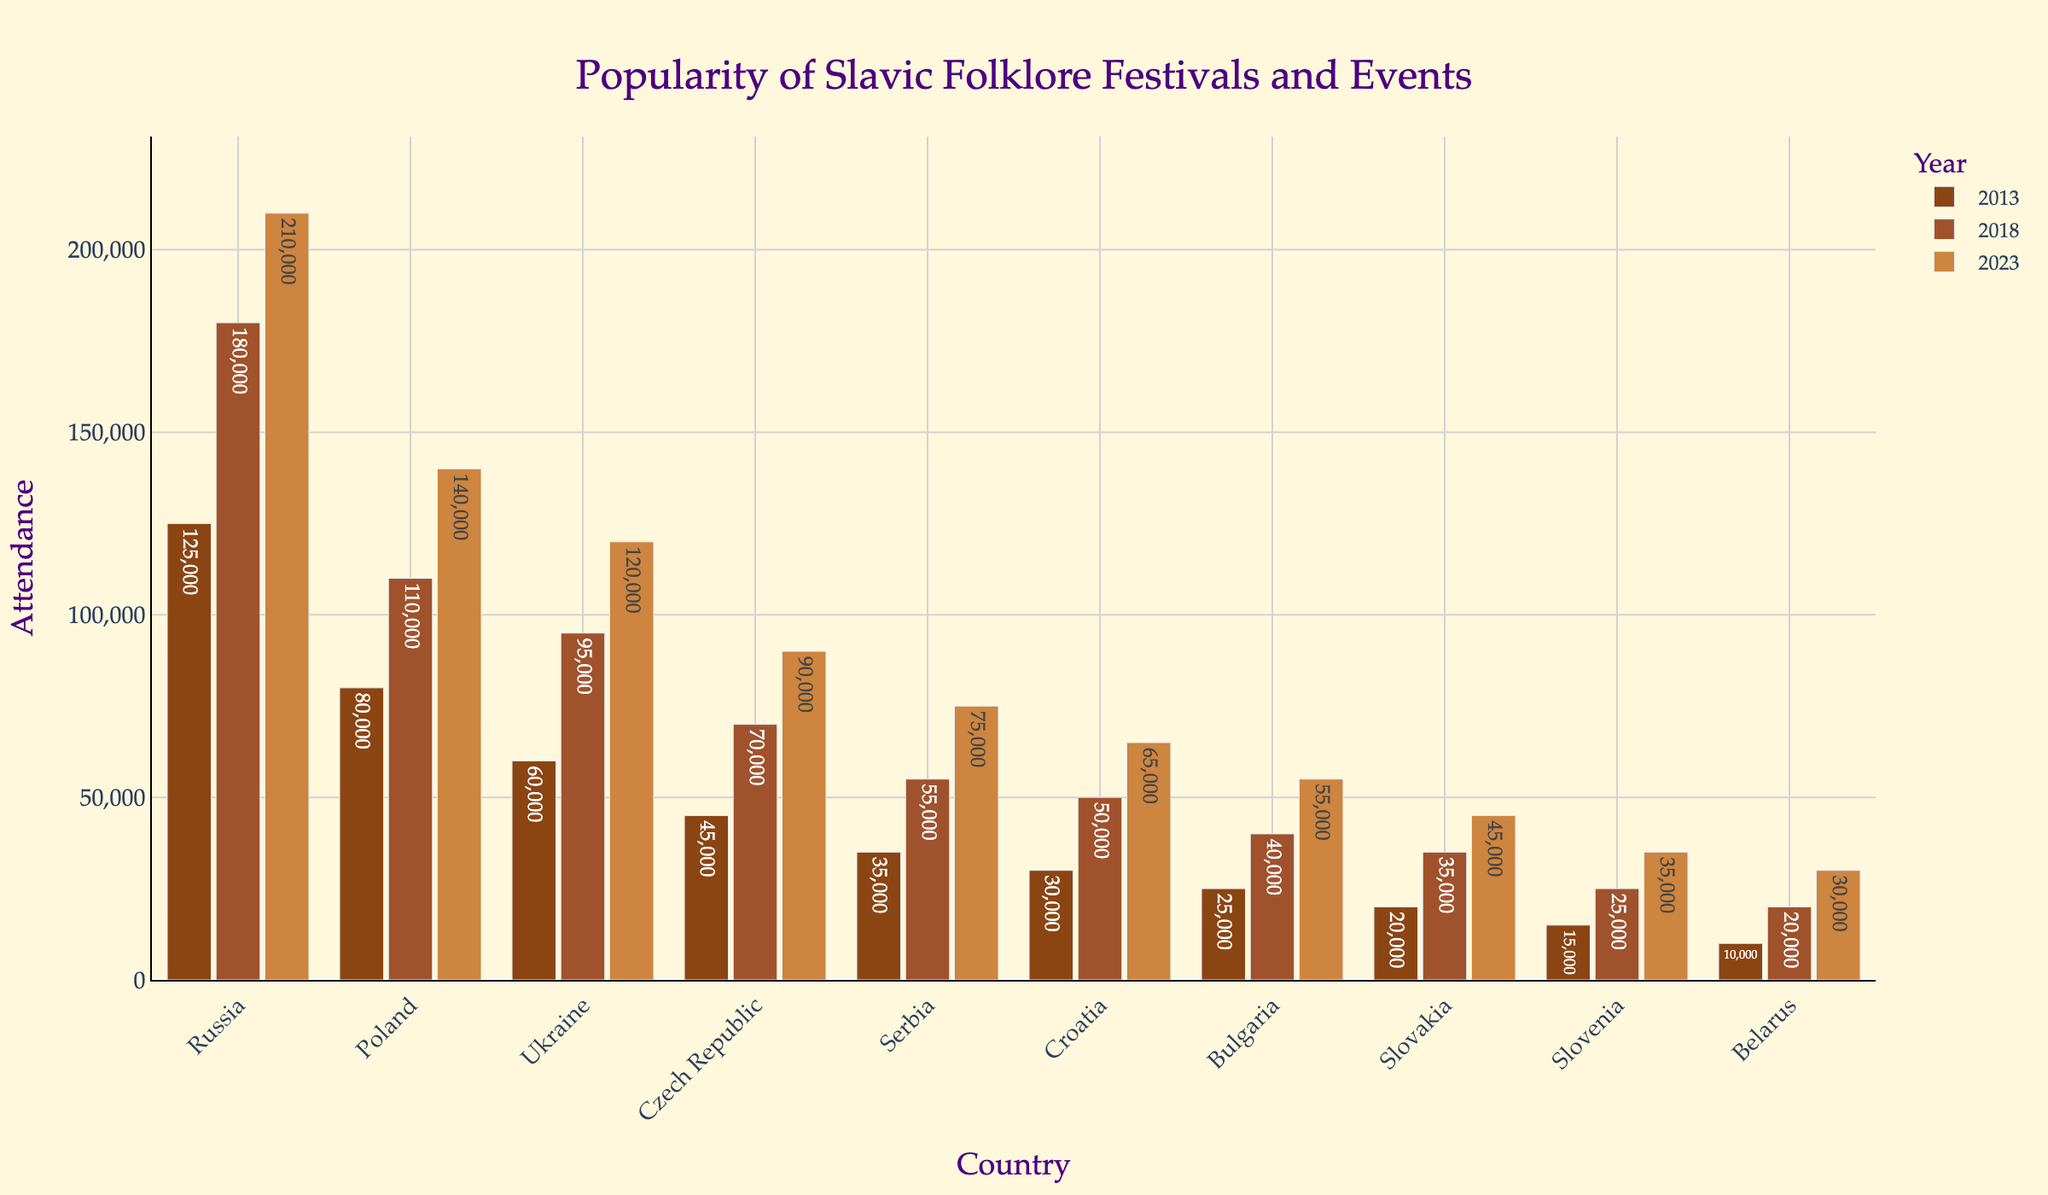What is the difference in attendance for Russia between 2013 and 2023? The attendance for Russia in 2013 was 125,000 and in 2023 it is 210,000. The difference is 210,000 - 125,000 = 85,000
Answer: 85,000 Which country had the highest attendance in 2023 and what was the value? By looking at the heights of the bars for 2023, Russia had the highest attendance with a value of 210,000
Answer: Russia, 210,000 How much did the attendance in Poland increase from 2013 to 2023? The attendance in Poland in 2013 was 80,000 and in 2023 it was 140,000. The increase is 140,000 - 80,000 = 60,000
Answer: 60,000 Which two countries had the closest attendance values in 2018 and what were those values? By comparing the heights of the bars in 2018, Serbia and Croatia had the closest values, with Serbia having 55,000 and Croatia 50,000
Answer: Serbia (55,000), Croatia (50,000) What is the average attendance of Bulgarian folklore festivals and events over the three years represented? The attendance values for Bulgaria are 25,000 (2013), 40,000 (2018), and 55,000 (2023). The average is (25,000 + 40,000 + 55,000) / 3 = 40,000
Answer: 40,000 Which country showed the least growth in attendance from 2013 to 2023? By comparing the differences in attendance from 2013 to 2023 for each country, Slovenia showed the least growth with values 15,000 (2013) and 35,000 (2023), the growth is 20,000
Answer: Slovenia Between Russia and Poland, which country had a smaller increase in attendance from 2018 to 2023? Russia's increase from 2018 (180,000) to 2023 (210,000) is 30,000, and Poland's increase from 2018 (110,000) to 2023 (140,000) is also 30,000. The increases are equal.
Answer: Equal What is the total attendance for the Czech Republic for all the year tiers combined? The attendance values for the Czech Republic are 45,000 (2013), 70,000 (2018), and 90,000 (2023). The total is 45,000 + 70,000 + 90,000 = 205,000
Answer: 205,000 By how much did the attendance in Serbia increase from 2013 to 2018 compared to its increase from 2018 to 2023? The increase from 2013 (35,000) to 2018 (55,000) is 20,000. The increase from 2018 (55,000) to 2023 (75,000) is also 20,000. The increases are the same.
Answer: Same Looking at 2023, which countries have an attendance lower than 100,000? For the year 2023, countries with attendance values lower than 100,000 are Czech Republic (90,000), Serbia (75,000), Croatia (65,000), Bulgaria (55,000), Slovakia (45,000), Slovenia (35,000), and Belarus (30,000)
Answer: Czech Republic, Serbia, Croatia, Bulgaria, Slovakia, Slovenia, Belarus 